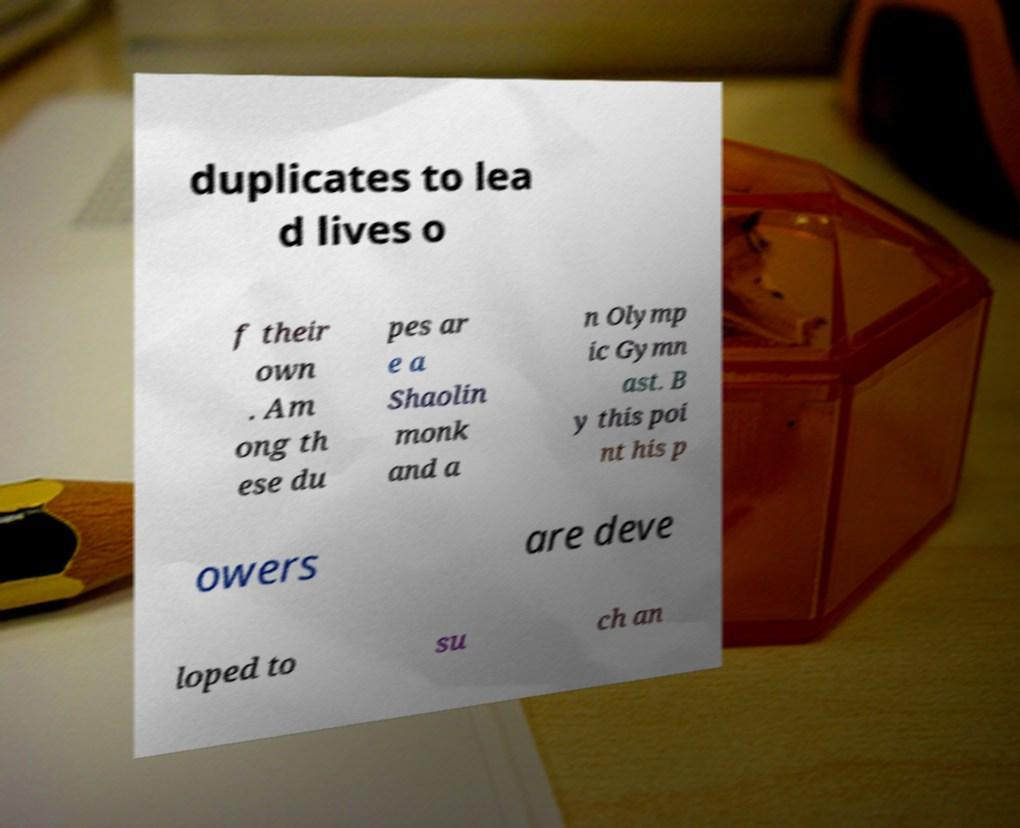What messages or text are displayed in this image? I need them in a readable, typed format. duplicates to lea d lives o f their own . Am ong th ese du pes ar e a Shaolin monk and a n Olymp ic Gymn ast. B y this poi nt his p owers are deve loped to su ch an 